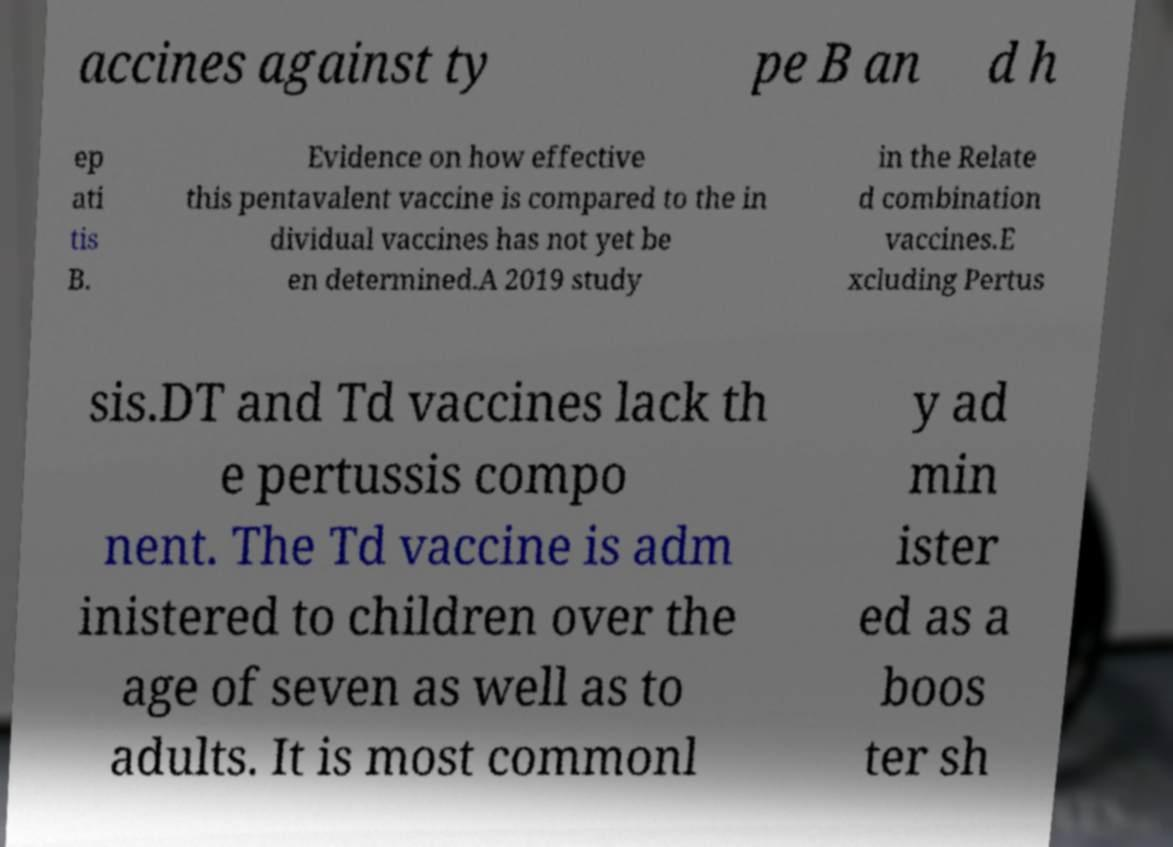Could you extract and type out the text from this image? accines against ty pe B an d h ep ati tis B. Evidence on how effective this pentavalent vaccine is compared to the in dividual vaccines has not yet be en determined.A 2019 study in the Relate d combination vaccines.E xcluding Pertus sis.DT and Td vaccines lack th e pertussis compo nent. The Td vaccine is adm inistered to children over the age of seven as well as to adults. It is most commonl y ad min ister ed as a boos ter sh 